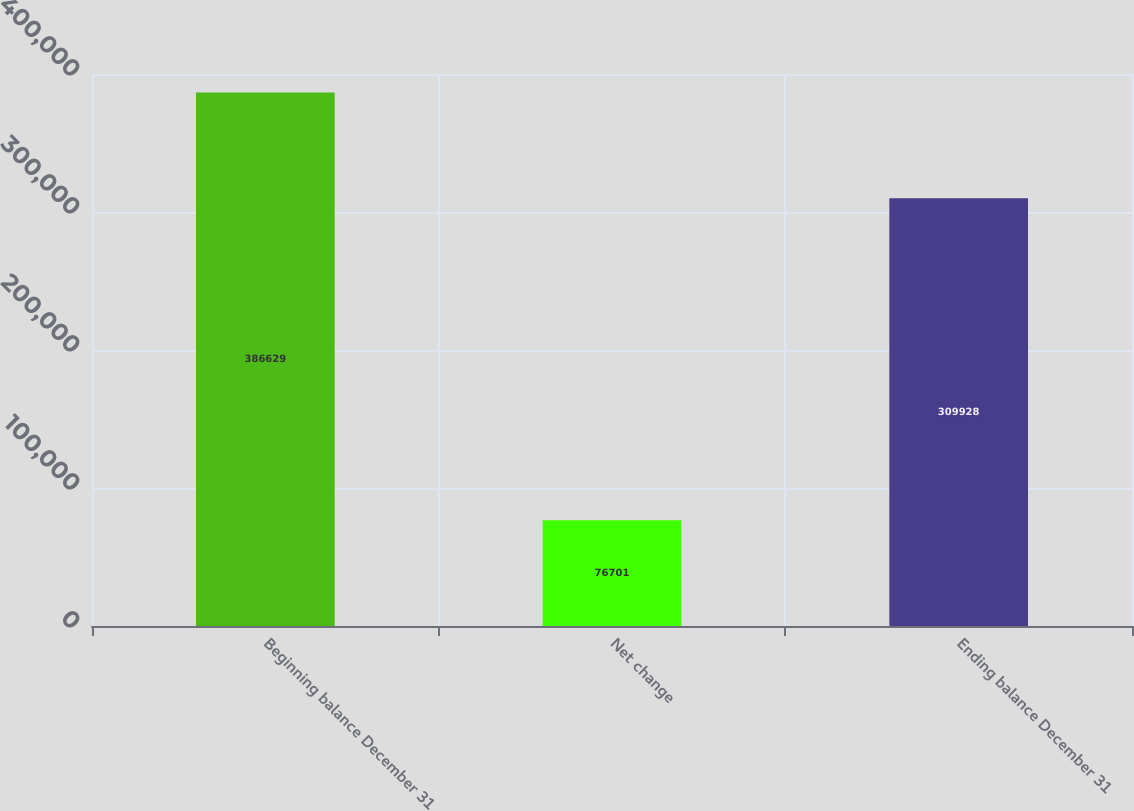Convert chart to OTSL. <chart><loc_0><loc_0><loc_500><loc_500><bar_chart><fcel>Beginning balance December 31<fcel>Net change<fcel>Ending balance December 31<nl><fcel>386629<fcel>76701<fcel>309928<nl></chart> 